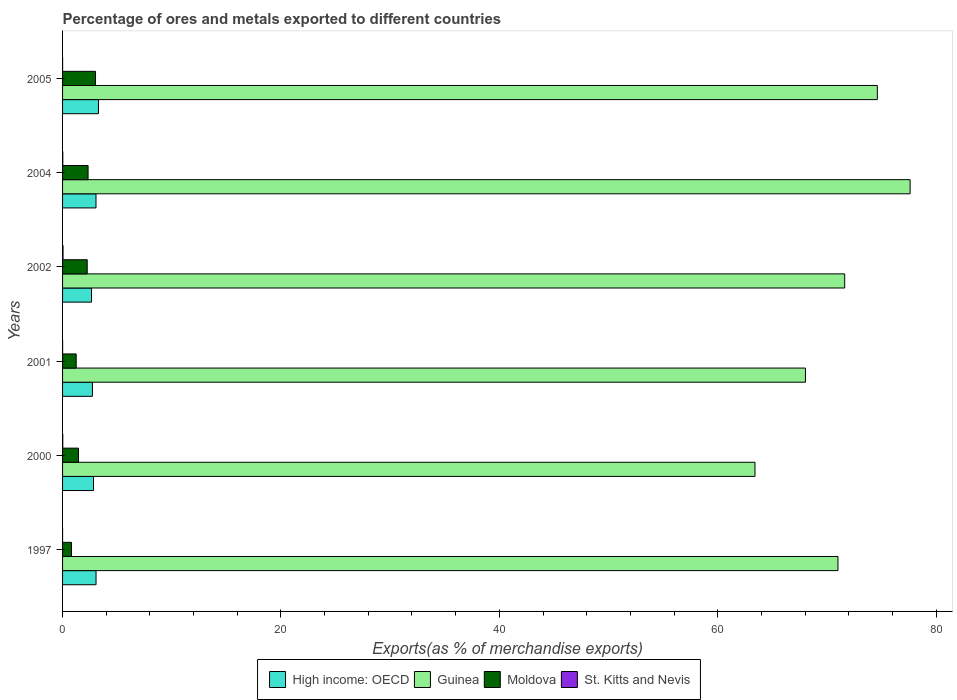Are the number of bars on each tick of the Y-axis equal?
Offer a very short reply. Yes. How many bars are there on the 6th tick from the top?
Offer a terse response. 4. What is the percentage of exports to different countries in Guinea in 2004?
Ensure brevity in your answer.  77.62. Across all years, what is the maximum percentage of exports to different countries in Moldova?
Provide a short and direct response. 3.02. Across all years, what is the minimum percentage of exports to different countries in Guinea?
Ensure brevity in your answer.  63.41. In which year was the percentage of exports to different countries in Guinea maximum?
Make the answer very short. 2004. In which year was the percentage of exports to different countries in High income: OECD minimum?
Your answer should be compact. 2002. What is the total percentage of exports to different countries in Guinea in the graph?
Your answer should be compact. 426.32. What is the difference between the percentage of exports to different countries in High income: OECD in 2000 and that in 2004?
Your answer should be compact. -0.23. What is the difference between the percentage of exports to different countries in High income: OECD in 1997 and the percentage of exports to different countries in Moldova in 2002?
Keep it short and to the point. 0.81. What is the average percentage of exports to different countries in Guinea per year?
Give a very brief answer. 71.05. In the year 2004, what is the difference between the percentage of exports to different countries in Guinea and percentage of exports to different countries in St. Kitts and Nevis?
Offer a terse response. 77.6. What is the ratio of the percentage of exports to different countries in Guinea in 2000 to that in 2002?
Give a very brief answer. 0.89. What is the difference between the highest and the second highest percentage of exports to different countries in High income: OECD?
Offer a very short reply. 0.22. What is the difference between the highest and the lowest percentage of exports to different countries in High income: OECD?
Offer a terse response. 0.63. Is the sum of the percentage of exports to different countries in Moldova in 2001 and 2002 greater than the maximum percentage of exports to different countries in High income: OECD across all years?
Offer a very short reply. Yes. What does the 1st bar from the top in 2001 represents?
Your answer should be very brief. St. Kitts and Nevis. What does the 3rd bar from the bottom in 1997 represents?
Your response must be concise. Moldova. How many bars are there?
Your answer should be compact. 24. What is the difference between two consecutive major ticks on the X-axis?
Offer a terse response. 20. Are the values on the major ticks of X-axis written in scientific E-notation?
Provide a short and direct response. No. Does the graph contain grids?
Your answer should be compact. No. Where does the legend appear in the graph?
Provide a succinct answer. Bottom center. How many legend labels are there?
Provide a short and direct response. 4. How are the legend labels stacked?
Give a very brief answer. Horizontal. What is the title of the graph?
Offer a terse response. Percentage of ores and metals exported to different countries. What is the label or title of the X-axis?
Offer a terse response. Exports(as % of merchandise exports). What is the Exports(as % of merchandise exports) of High income: OECD in 1997?
Keep it short and to the point. 3.07. What is the Exports(as % of merchandise exports) of Guinea in 1997?
Your answer should be very brief. 71.01. What is the Exports(as % of merchandise exports) in Moldova in 1997?
Make the answer very short. 0.82. What is the Exports(as % of merchandise exports) of St. Kitts and Nevis in 1997?
Provide a succinct answer. 0. What is the Exports(as % of merchandise exports) of High income: OECD in 2000?
Give a very brief answer. 2.83. What is the Exports(as % of merchandise exports) in Guinea in 2000?
Keep it short and to the point. 63.41. What is the Exports(as % of merchandise exports) in Moldova in 2000?
Offer a terse response. 1.46. What is the Exports(as % of merchandise exports) in St. Kitts and Nevis in 2000?
Your response must be concise. 0.02. What is the Exports(as % of merchandise exports) of High income: OECD in 2001?
Your answer should be very brief. 2.73. What is the Exports(as % of merchandise exports) of Guinea in 2001?
Keep it short and to the point. 68.03. What is the Exports(as % of merchandise exports) of Moldova in 2001?
Your answer should be very brief. 1.25. What is the Exports(as % of merchandise exports) in St. Kitts and Nevis in 2001?
Offer a very short reply. 0. What is the Exports(as % of merchandise exports) of High income: OECD in 2002?
Give a very brief answer. 2.65. What is the Exports(as % of merchandise exports) of Guinea in 2002?
Offer a very short reply. 71.63. What is the Exports(as % of merchandise exports) in Moldova in 2002?
Provide a short and direct response. 2.26. What is the Exports(as % of merchandise exports) in St. Kitts and Nevis in 2002?
Your answer should be compact. 0.04. What is the Exports(as % of merchandise exports) in High income: OECD in 2004?
Give a very brief answer. 3.06. What is the Exports(as % of merchandise exports) of Guinea in 2004?
Your response must be concise. 77.62. What is the Exports(as % of merchandise exports) of Moldova in 2004?
Your response must be concise. 2.34. What is the Exports(as % of merchandise exports) of St. Kitts and Nevis in 2004?
Offer a terse response. 0.02. What is the Exports(as % of merchandise exports) of High income: OECD in 2005?
Make the answer very short. 3.29. What is the Exports(as % of merchandise exports) in Guinea in 2005?
Provide a succinct answer. 74.62. What is the Exports(as % of merchandise exports) of Moldova in 2005?
Give a very brief answer. 3.02. What is the Exports(as % of merchandise exports) of St. Kitts and Nevis in 2005?
Your answer should be very brief. 0. Across all years, what is the maximum Exports(as % of merchandise exports) of High income: OECD?
Offer a very short reply. 3.29. Across all years, what is the maximum Exports(as % of merchandise exports) in Guinea?
Your answer should be compact. 77.62. Across all years, what is the maximum Exports(as % of merchandise exports) of Moldova?
Provide a short and direct response. 3.02. Across all years, what is the maximum Exports(as % of merchandise exports) in St. Kitts and Nevis?
Provide a short and direct response. 0.04. Across all years, what is the minimum Exports(as % of merchandise exports) of High income: OECD?
Offer a very short reply. 2.65. Across all years, what is the minimum Exports(as % of merchandise exports) of Guinea?
Offer a terse response. 63.41. Across all years, what is the minimum Exports(as % of merchandise exports) in Moldova?
Provide a succinct answer. 0.82. Across all years, what is the minimum Exports(as % of merchandise exports) in St. Kitts and Nevis?
Offer a terse response. 0. What is the total Exports(as % of merchandise exports) in High income: OECD in the graph?
Ensure brevity in your answer.  17.64. What is the total Exports(as % of merchandise exports) in Guinea in the graph?
Make the answer very short. 426.32. What is the total Exports(as % of merchandise exports) in Moldova in the graph?
Keep it short and to the point. 11.13. What is the total Exports(as % of merchandise exports) of St. Kitts and Nevis in the graph?
Keep it short and to the point. 0.09. What is the difference between the Exports(as % of merchandise exports) in High income: OECD in 1997 and that in 2000?
Keep it short and to the point. 0.23. What is the difference between the Exports(as % of merchandise exports) of Moldova in 1997 and that in 2000?
Keep it short and to the point. -0.64. What is the difference between the Exports(as % of merchandise exports) in St. Kitts and Nevis in 1997 and that in 2000?
Keep it short and to the point. -0.02. What is the difference between the Exports(as % of merchandise exports) in High income: OECD in 1997 and that in 2001?
Your answer should be compact. 0.33. What is the difference between the Exports(as % of merchandise exports) in Guinea in 1997 and that in 2001?
Offer a terse response. 2.98. What is the difference between the Exports(as % of merchandise exports) of Moldova in 1997 and that in 2001?
Offer a terse response. -0.43. What is the difference between the Exports(as % of merchandise exports) in St. Kitts and Nevis in 1997 and that in 2001?
Offer a very short reply. -0. What is the difference between the Exports(as % of merchandise exports) of High income: OECD in 1997 and that in 2002?
Offer a terse response. 0.41. What is the difference between the Exports(as % of merchandise exports) of Guinea in 1997 and that in 2002?
Keep it short and to the point. -0.61. What is the difference between the Exports(as % of merchandise exports) of Moldova in 1997 and that in 2002?
Offer a very short reply. -1.44. What is the difference between the Exports(as % of merchandise exports) in St. Kitts and Nevis in 1997 and that in 2002?
Your answer should be compact. -0.04. What is the difference between the Exports(as % of merchandise exports) of High income: OECD in 1997 and that in 2004?
Your answer should be very brief. 0. What is the difference between the Exports(as % of merchandise exports) in Guinea in 1997 and that in 2004?
Offer a very short reply. -6.61. What is the difference between the Exports(as % of merchandise exports) of Moldova in 1997 and that in 2004?
Provide a short and direct response. -1.52. What is the difference between the Exports(as % of merchandise exports) in St. Kitts and Nevis in 1997 and that in 2004?
Ensure brevity in your answer.  -0.02. What is the difference between the Exports(as % of merchandise exports) of High income: OECD in 1997 and that in 2005?
Offer a terse response. -0.22. What is the difference between the Exports(as % of merchandise exports) in Guinea in 1997 and that in 2005?
Ensure brevity in your answer.  -3.61. What is the difference between the Exports(as % of merchandise exports) in Moldova in 1997 and that in 2005?
Your response must be concise. -2.2. What is the difference between the Exports(as % of merchandise exports) of St. Kitts and Nevis in 1997 and that in 2005?
Provide a succinct answer. -0. What is the difference between the Exports(as % of merchandise exports) of High income: OECD in 2000 and that in 2001?
Give a very brief answer. 0.1. What is the difference between the Exports(as % of merchandise exports) in Guinea in 2000 and that in 2001?
Your answer should be compact. -4.62. What is the difference between the Exports(as % of merchandise exports) in Moldova in 2000 and that in 2001?
Offer a very short reply. 0.21. What is the difference between the Exports(as % of merchandise exports) of St. Kitts and Nevis in 2000 and that in 2001?
Give a very brief answer. 0.02. What is the difference between the Exports(as % of merchandise exports) of High income: OECD in 2000 and that in 2002?
Ensure brevity in your answer.  0.18. What is the difference between the Exports(as % of merchandise exports) of Guinea in 2000 and that in 2002?
Keep it short and to the point. -8.21. What is the difference between the Exports(as % of merchandise exports) in Moldova in 2000 and that in 2002?
Your answer should be very brief. -0.8. What is the difference between the Exports(as % of merchandise exports) in St. Kitts and Nevis in 2000 and that in 2002?
Ensure brevity in your answer.  -0.02. What is the difference between the Exports(as % of merchandise exports) of High income: OECD in 2000 and that in 2004?
Keep it short and to the point. -0.23. What is the difference between the Exports(as % of merchandise exports) in Guinea in 2000 and that in 2004?
Offer a very short reply. -14.21. What is the difference between the Exports(as % of merchandise exports) in Moldova in 2000 and that in 2004?
Give a very brief answer. -0.88. What is the difference between the Exports(as % of merchandise exports) in St. Kitts and Nevis in 2000 and that in 2004?
Provide a succinct answer. -0. What is the difference between the Exports(as % of merchandise exports) of High income: OECD in 2000 and that in 2005?
Ensure brevity in your answer.  -0.45. What is the difference between the Exports(as % of merchandise exports) in Guinea in 2000 and that in 2005?
Keep it short and to the point. -11.21. What is the difference between the Exports(as % of merchandise exports) in Moldova in 2000 and that in 2005?
Provide a short and direct response. -1.56. What is the difference between the Exports(as % of merchandise exports) in St. Kitts and Nevis in 2000 and that in 2005?
Make the answer very short. 0.02. What is the difference between the Exports(as % of merchandise exports) in High income: OECD in 2001 and that in 2002?
Your answer should be compact. 0.08. What is the difference between the Exports(as % of merchandise exports) in Guinea in 2001 and that in 2002?
Your answer should be compact. -3.59. What is the difference between the Exports(as % of merchandise exports) in Moldova in 2001 and that in 2002?
Your answer should be compact. -1.01. What is the difference between the Exports(as % of merchandise exports) in St. Kitts and Nevis in 2001 and that in 2002?
Provide a short and direct response. -0.04. What is the difference between the Exports(as % of merchandise exports) in High income: OECD in 2001 and that in 2004?
Provide a short and direct response. -0.33. What is the difference between the Exports(as % of merchandise exports) of Guinea in 2001 and that in 2004?
Ensure brevity in your answer.  -9.58. What is the difference between the Exports(as % of merchandise exports) of Moldova in 2001 and that in 2004?
Offer a very short reply. -1.09. What is the difference between the Exports(as % of merchandise exports) in St. Kitts and Nevis in 2001 and that in 2004?
Keep it short and to the point. -0.02. What is the difference between the Exports(as % of merchandise exports) in High income: OECD in 2001 and that in 2005?
Your response must be concise. -0.55. What is the difference between the Exports(as % of merchandise exports) of Guinea in 2001 and that in 2005?
Give a very brief answer. -6.58. What is the difference between the Exports(as % of merchandise exports) of Moldova in 2001 and that in 2005?
Your answer should be compact. -1.77. What is the difference between the Exports(as % of merchandise exports) in St. Kitts and Nevis in 2001 and that in 2005?
Your answer should be very brief. 0. What is the difference between the Exports(as % of merchandise exports) in High income: OECD in 2002 and that in 2004?
Make the answer very short. -0.41. What is the difference between the Exports(as % of merchandise exports) in Guinea in 2002 and that in 2004?
Your response must be concise. -5.99. What is the difference between the Exports(as % of merchandise exports) of Moldova in 2002 and that in 2004?
Keep it short and to the point. -0.08. What is the difference between the Exports(as % of merchandise exports) of St. Kitts and Nevis in 2002 and that in 2004?
Provide a short and direct response. 0.02. What is the difference between the Exports(as % of merchandise exports) of High income: OECD in 2002 and that in 2005?
Provide a short and direct response. -0.63. What is the difference between the Exports(as % of merchandise exports) of Guinea in 2002 and that in 2005?
Provide a succinct answer. -2.99. What is the difference between the Exports(as % of merchandise exports) in Moldova in 2002 and that in 2005?
Your answer should be compact. -0.76. What is the difference between the Exports(as % of merchandise exports) in High income: OECD in 2004 and that in 2005?
Keep it short and to the point. -0.22. What is the difference between the Exports(as % of merchandise exports) of Guinea in 2004 and that in 2005?
Provide a succinct answer. 3. What is the difference between the Exports(as % of merchandise exports) of Moldova in 2004 and that in 2005?
Give a very brief answer. -0.68. What is the difference between the Exports(as % of merchandise exports) in St. Kitts and Nevis in 2004 and that in 2005?
Offer a very short reply. 0.02. What is the difference between the Exports(as % of merchandise exports) of High income: OECD in 1997 and the Exports(as % of merchandise exports) of Guinea in 2000?
Provide a succinct answer. -60.35. What is the difference between the Exports(as % of merchandise exports) of High income: OECD in 1997 and the Exports(as % of merchandise exports) of Moldova in 2000?
Offer a terse response. 1.61. What is the difference between the Exports(as % of merchandise exports) of High income: OECD in 1997 and the Exports(as % of merchandise exports) of St. Kitts and Nevis in 2000?
Make the answer very short. 3.05. What is the difference between the Exports(as % of merchandise exports) in Guinea in 1997 and the Exports(as % of merchandise exports) in Moldova in 2000?
Keep it short and to the point. 69.55. What is the difference between the Exports(as % of merchandise exports) of Guinea in 1997 and the Exports(as % of merchandise exports) of St. Kitts and Nevis in 2000?
Offer a very short reply. 70.99. What is the difference between the Exports(as % of merchandise exports) in Moldova in 1997 and the Exports(as % of merchandise exports) in St. Kitts and Nevis in 2000?
Provide a succinct answer. 0.8. What is the difference between the Exports(as % of merchandise exports) in High income: OECD in 1997 and the Exports(as % of merchandise exports) in Guinea in 2001?
Give a very brief answer. -64.97. What is the difference between the Exports(as % of merchandise exports) in High income: OECD in 1997 and the Exports(as % of merchandise exports) in Moldova in 2001?
Your answer should be compact. 1.82. What is the difference between the Exports(as % of merchandise exports) in High income: OECD in 1997 and the Exports(as % of merchandise exports) in St. Kitts and Nevis in 2001?
Provide a succinct answer. 3.06. What is the difference between the Exports(as % of merchandise exports) in Guinea in 1997 and the Exports(as % of merchandise exports) in Moldova in 2001?
Keep it short and to the point. 69.76. What is the difference between the Exports(as % of merchandise exports) in Guinea in 1997 and the Exports(as % of merchandise exports) in St. Kitts and Nevis in 2001?
Offer a terse response. 71.01. What is the difference between the Exports(as % of merchandise exports) of Moldova in 1997 and the Exports(as % of merchandise exports) of St. Kitts and Nevis in 2001?
Provide a succinct answer. 0.81. What is the difference between the Exports(as % of merchandise exports) in High income: OECD in 1997 and the Exports(as % of merchandise exports) in Guinea in 2002?
Make the answer very short. -68.56. What is the difference between the Exports(as % of merchandise exports) in High income: OECD in 1997 and the Exports(as % of merchandise exports) in Moldova in 2002?
Your answer should be compact. 0.81. What is the difference between the Exports(as % of merchandise exports) of High income: OECD in 1997 and the Exports(as % of merchandise exports) of St. Kitts and Nevis in 2002?
Your answer should be very brief. 3.02. What is the difference between the Exports(as % of merchandise exports) in Guinea in 1997 and the Exports(as % of merchandise exports) in Moldova in 2002?
Your answer should be very brief. 68.76. What is the difference between the Exports(as % of merchandise exports) in Guinea in 1997 and the Exports(as % of merchandise exports) in St. Kitts and Nevis in 2002?
Keep it short and to the point. 70.97. What is the difference between the Exports(as % of merchandise exports) in Moldova in 1997 and the Exports(as % of merchandise exports) in St. Kitts and Nevis in 2002?
Offer a terse response. 0.78. What is the difference between the Exports(as % of merchandise exports) of High income: OECD in 1997 and the Exports(as % of merchandise exports) of Guinea in 2004?
Your answer should be very brief. -74.55. What is the difference between the Exports(as % of merchandise exports) of High income: OECD in 1997 and the Exports(as % of merchandise exports) of Moldova in 2004?
Your answer should be very brief. 0.73. What is the difference between the Exports(as % of merchandise exports) of High income: OECD in 1997 and the Exports(as % of merchandise exports) of St. Kitts and Nevis in 2004?
Provide a succinct answer. 3.04. What is the difference between the Exports(as % of merchandise exports) of Guinea in 1997 and the Exports(as % of merchandise exports) of Moldova in 2004?
Make the answer very short. 68.68. What is the difference between the Exports(as % of merchandise exports) in Guinea in 1997 and the Exports(as % of merchandise exports) in St. Kitts and Nevis in 2004?
Provide a succinct answer. 70.99. What is the difference between the Exports(as % of merchandise exports) of Moldova in 1997 and the Exports(as % of merchandise exports) of St. Kitts and Nevis in 2004?
Your answer should be very brief. 0.8. What is the difference between the Exports(as % of merchandise exports) of High income: OECD in 1997 and the Exports(as % of merchandise exports) of Guinea in 2005?
Your answer should be compact. -71.55. What is the difference between the Exports(as % of merchandise exports) of High income: OECD in 1997 and the Exports(as % of merchandise exports) of Moldova in 2005?
Give a very brief answer. 0.05. What is the difference between the Exports(as % of merchandise exports) in High income: OECD in 1997 and the Exports(as % of merchandise exports) in St. Kitts and Nevis in 2005?
Provide a short and direct response. 3.06. What is the difference between the Exports(as % of merchandise exports) in Guinea in 1997 and the Exports(as % of merchandise exports) in Moldova in 2005?
Your answer should be very brief. 67.99. What is the difference between the Exports(as % of merchandise exports) in Guinea in 1997 and the Exports(as % of merchandise exports) in St. Kitts and Nevis in 2005?
Make the answer very short. 71.01. What is the difference between the Exports(as % of merchandise exports) in Moldova in 1997 and the Exports(as % of merchandise exports) in St. Kitts and Nevis in 2005?
Your answer should be very brief. 0.82. What is the difference between the Exports(as % of merchandise exports) of High income: OECD in 2000 and the Exports(as % of merchandise exports) of Guinea in 2001?
Ensure brevity in your answer.  -65.2. What is the difference between the Exports(as % of merchandise exports) in High income: OECD in 2000 and the Exports(as % of merchandise exports) in Moldova in 2001?
Your answer should be very brief. 1.59. What is the difference between the Exports(as % of merchandise exports) of High income: OECD in 2000 and the Exports(as % of merchandise exports) of St. Kitts and Nevis in 2001?
Offer a very short reply. 2.83. What is the difference between the Exports(as % of merchandise exports) in Guinea in 2000 and the Exports(as % of merchandise exports) in Moldova in 2001?
Offer a terse response. 62.16. What is the difference between the Exports(as % of merchandise exports) in Guinea in 2000 and the Exports(as % of merchandise exports) in St. Kitts and Nevis in 2001?
Provide a succinct answer. 63.41. What is the difference between the Exports(as % of merchandise exports) in Moldova in 2000 and the Exports(as % of merchandise exports) in St. Kitts and Nevis in 2001?
Ensure brevity in your answer.  1.45. What is the difference between the Exports(as % of merchandise exports) in High income: OECD in 2000 and the Exports(as % of merchandise exports) in Guinea in 2002?
Your response must be concise. -68.79. What is the difference between the Exports(as % of merchandise exports) in High income: OECD in 2000 and the Exports(as % of merchandise exports) in Moldova in 2002?
Provide a succinct answer. 0.58. What is the difference between the Exports(as % of merchandise exports) in High income: OECD in 2000 and the Exports(as % of merchandise exports) in St. Kitts and Nevis in 2002?
Your answer should be compact. 2.79. What is the difference between the Exports(as % of merchandise exports) of Guinea in 2000 and the Exports(as % of merchandise exports) of Moldova in 2002?
Your response must be concise. 61.16. What is the difference between the Exports(as % of merchandise exports) of Guinea in 2000 and the Exports(as % of merchandise exports) of St. Kitts and Nevis in 2002?
Make the answer very short. 63.37. What is the difference between the Exports(as % of merchandise exports) of Moldova in 2000 and the Exports(as % of merchandise exports) of St. Kitts and Nevis in 2002?
Make the answer very short. 1.42. What is the difference between the Exports(as % of merchandise exports) of High income: OECD in 2000 and the Exports(as % of merchandise exports) of Guinea in 2004?
Your answer should be very brief. -74.78. What is the difference between the Exports(as % of merchandise exports) in High income: OECD in 2000 and the Exports(as % of merchandise exports) in Moldova in 2004?
Provide a short and direct response. 0.5. What is the difference between the Exports(as % of merchandise exports) of High income: OECD in 2000 and the Exports(as % of merchandise exports) of St. Kitts and Nevis in 2004?
Provide a short and direct response. 2.81. What is the difference between the Exports(as % of merchandise exports) of Guinea in 2000 and the Exports(as % of merchandise exports) of Moldova in 2004?
Give a very brief answer. 61.08. What is the difference between the Exports(as % of merchandise exports) of Guinea in 2000 and the Exports(as % of merchandise exports) of St. Kitts and Nevis in 2004?
Offer a terse response. 63.39. What is the difference between the Exports(as % of merchandise exports) of Moldova in 2000 and the Exports(as % of merchandise exports) of St. Kitts and Nevis in 2004?
Your answer should be very brief. 1.44. What is the difference between the Exports(as % of merchandise exports) in High income: OECD in 2000 and the Exports(as % of merchandise exports) in Guinea in 2005?
Your answer should be very brief. -71.78. What is the difference between the Exports(as % of merchandise exports) in High income: OECD in 2000 and the Exports(as % of merchandise exports) in Moldova in 2005?
Your response must be concise. -0.18. What is the difference between the Exports(as % of merchandise exports) of High income: OECD in 2000 and the Exports(as % of merchandise exports) of St. Kitts and Nevis in 2005?
Keep it short and to the point. 2.83. What is the difference between the Exports(as % of merchandise exports) in Guinea in 2000 and the Exports(as % of merchandise exports) in Moldova in 2005?
Provide a succinct answer. 60.39. What is the difference between the Exports(as % of merchandise exports) of Guinea in 2000 and the Exports(as % of merchandise exports) of St. Kitts and Nevis in 2005?
Your response must be concise. 63.41. What is the difference between the Exports(as % of merchandise exports) in Moldova in 2000 and the Exports(as % of merchandise exports) in St. Kitts and Nevis in 2005?
Provide a short and direct response. 1.46. What is the difference between the Exports(as % of merchandise exports) of High income: OECD in 2001 and the Exports(as % of merchandise exports) of Guinea in 2002?
Give a very brief answer. -68.89. What is the difference between the Exports(as % of merchandise exports) in High income: OECD in 2001 and the Exports(as % of merchandise exports) in Moldova in 2002?
Your answer should be compact. 0.48. What is the difference between the Exports(as % of merchandise exports) in High income: OECD in 2001 and the Exports(as % of merchandise exports) in St. Kitts and Nevis in 2002?
Ensure brevity in your answer.  2.69. What is the difference between the Exports(as % of merchandise exports) of Guinea in 2001 and the Exports(as % of merchandise exports) of Moldova in 2002?
Provide a succinct answer. 65.78. What is the difference between the Exports(as % of merchandise exports) in Guinea in 2001 and the Exports(as % of merchandise exports) in St. Kitts and Nevis in 2002?
Give a very brief answer. 67.99. What is the difference between the Exports(as % of merchandise exports) in Moldova in 2001 and the Exports(as % of merchandise exports) in St. Kitts and Nevis in 2002?
Offer a very short reply. 1.2. What is the difference between the Exports(as % of merchandise exports) of High income: OECD in 2001 and the Exports(as % of merchandise exports) of Guinea in 2004?
Make the answer very short. -74.88. What is the difference between the Exports(as % of merchandise exports) of High income: OECD in 2001 and the Exports(as % of merchandise exports) of Moldova in 2004?
Make the answer very short. 0.4. What is the difference between the Exports(as % of merchandise exports) in High income: OECD in 2001 and the Exports(as % of merchandise exports) in St. Kitts and Nevis in 2004?
Your answer should be compact. 2.71. What is the difference between the Exports(as % of merchandise exports) of Guinea in 2001 and the Exports(as % of merchandise exports) of Moldova in 2004?
Provide a succinct answer. 65.7. What is the difference between the Exports(as % of merchandise exports) in Guinea in 2001 and the Exports(as % of merchandise exports) in St. Kitts and Nevis in 2004?
Your answer should be very brief. 68.01. What is the difference between the Exports(as % of merchandise exports) of Moldova in 2001 and the Exports(as % of merchandise exports) of St. Kitts and Nevis in 2004?
Your response must be concise. 1.23. What is the difference between the Exports(as % of merchandise exports) of High income: OECD in 2001 and the Exports(as % of merchandise exports) of Guinea in 2005?
Provide a short and direct response. -71.88. What is the difference between the Exports(as % of merchandise exports) of High income: OECD in 2001 and the Exports(as % of merchandise exports) of Moldova in 2005?
Keep it short and to the point. -0.28. What is the difference between the Exports(as % of merchandise exports) in High income: OECD in 2001 and the Exports(as % of merchandise exports) in St. Kitts and Nevis in 2005?
Your answer should be very brief. 2.73. What is the difference between the Exports(as % of merchandise exports) of Guinea in 2001 and the Exports(as % of merchandise exports) of Moldova in 2005?
Keep it short and to the point. 65.02. What is the difference between the Exports(as % of merchandise exports) in Guinea in 2001 and the Exports(as % of merchandise exports) in St. Kitts and Nevis in 2005?
Offer a very short reply. 68.03. What is the difference between the Exports(as % of merchandise exports) in Moldova in 2001 and the Exports(as % of merchandise exports) in St. Kitts and Nevis in 2005?
Offer a terse response. 1.24. What is the difference between the Exports(as % of merchandise exports) of High income: OECD in 2002 and the Exports(as % of merchandise exports) of Guinea in 2004?
Provide a short and direct response. -74.96. What is the difference between the Exports(as % of merchandise exports) of High income: OECD in 2002 and the Exports(as % of merchandise exports) of Moldova in 2004?
Provide a succinct answer. 0.32. What is the difference between the Exports(as % of merchandise exports) in High income: OECD in 2002 and the Exports(as % of merchandise exports) in St. Kitts and Nevis in 2004?
Ensure brevity in your answer.  2.63. What is the difference between the Exports(as % of merchandise exports) in Guinea in 2002 and the Exports(as % of merchandise exports) in Moldova in 2004?
Keep it short and to the point. 69.29. What is the difference between the Exports(as % of merchandise exports) in Guinea in 2002 and the Exports(as % of merchandise exports) in St. Kitts and Nevis in 2004?
Provide a short and direct response. 71.6. What is the difference between the Exports(as % of merchandise exports) of Moldova in 2002 and the Exports(as % of merchandise exports) of St. Kitts and Nevis in 2004?
Offer a very short reply. 2.24. What is the difference between the Exports(as % of merchandise exports) of High income: OECD in 2002 and the Exports(as % of merchandise exports) of Guinea in 2005?
Give a very brief answer. -71.96. What is the difference between the Exports(as % of merchandise exports) of High income: OECD in 2002 and the Exports(as % of merchandise exports) of Moldova in 2005?
Ensure brevity in your answer.  -0.36. What is the difference between the Exports(as % of merchandise exports) of High income: OECD in 2002 and the Exports(as % of merchandise exports) of St. Kitts and Nevis in 2005?
Your response must be concise. 2.65. What is the difference between the Exports(as % of merchandise exports) of Guinea in 2002 and the Exports(as % of merchandise exports) of Moldova in 2005?
Your answer should be very brief. 68.61. What is the difference between the Exports(as % of merchandise exports) in Guinea in 2002 and the Exports(as % of merchandise exports) in St. Kitts and Nevis in 2005?
Your answer should be very brief. 71.62. What is the difference between the Exports(as % of merchandise exports) in Moldova in 2002 and the Exports(as % of merchandise exports) in St. Kitts and Nevis in 2005?
Provide a succinct answer. 2.25. What is the difference between the Exports(as % of merchandise exports) in High income: OECD in 2004 and the Exports(as % of merchandise exports) in Guinea in 2005?
Your response must be concise. -71.55. What is the difference between the Exports(as % of merchandise exports) of High income: OECD in 2004 and the Exports(as % of merchandise exports) of Moldova in 2005?
Your answer should be compact. 0.04. What is the difference between the Exports(as % of merchandise exports) of High income: OECD in 2004 and the Exports(as % of merchandise exports) of St. Kitts and Nevis in 2005?
Provide a succinct answer. 3.06. What is the difference between the Exports(as % of merchandise exports) of Guinea in 2004 and the Exports(as % of merchandise exports) of Moldova in 2005?
Ensure brevity in your answer.  74.6. What is the difference between the Exports(as % of merchandise exports) in Guinea in 2004 and the Exports(as % of merchandise exports) in St. Kitts and Nevis in 2005?
Provide a succinct answer. 77.62. What is the difference between the Exports(as % of merchandise exports) in Moldova in 2004 and the Exports(as % of merchandise exports) in St. Kitts and Nevis in 2005?
Offer a very short reply. 2.33. What is the average Exports(as % of merchandise exports) in High income: OECD per year?
Your response must be concise. 2.94. What is the average Exports(as % of merchandise exports) of Guinea per year?
Offer a terse response. 71.05. What is the average Exports(as % of merchandise exports) of Moldova per year?
Your answer should be compact. 1.86. What is the average Exports(as % of merchandise exports) of St. Kitts and Nevis per year?
Offer a very short reply. 0.01. In the year 1997, what is the difference between the Exports(as % of merchandise exports) in High income: OECD and Exports(as % of merchandise exports) in Guinea?
Offer a terse response. -67.95. In the year 1997, what is the difference between the Exports(as % of merchandise exports) of High income: OECD and Exports(as % of merchandise exports) of Moldova?
Offer a terse response. 2.25. In the year 1997, what is the difference between the Exports(as % of merchandise exports) in High income: OECD and Exports(as % of merchandise exports) in St. Kitts and Nevis?
Offer a terse response. 3.07. In the year 1997, what is the difference between the Exports(as % of merchandise exports) of Guinea and Exports(as % of merchandise exports) of Moldova?
Ensure brevity in your answer.  70.19. In the year 1997, what is the difference between the Exports(as % of merchandise exports) in Guinea and Exports(as % of merchandise exports) in St. Kitts and Nevis?
Offer a terse response. 71.01. In the year 1997, what is the difference between the Exports(as % of merchandise exports) of Moldova and Exports(as % of merchandise exports) of St. Kitts and Nevis?
Ensure brevity in your answer.  0.82. In the year 2000, what is the difference between the Exports(as % of merchandise exports) of High income: OECD and Exports(as % of merchandise exports) of Guinea?
Keep it short and to the point. -60.58. In the year 2000, what is the difference between the Exports(as % of merchandise exports) of High income: OECD and Exports(as % of merchandise exports) of Moldova?
Provide a succinct answer. 1.38. In the year 2000, what is the difference between the Exports(as % of merchandise exports) in High income: OECD and Exports(as % of merchandise exports) in St. Kitts and Nevis?
Provide a short and direct response. 2.81. In the year 2000, what is the difference between the Exports(as % of merchandise exports) in Guinea and Exports(as % of merchandise exports) in Moldova?
Make the answer very short. 61.95. In the year 2000, what is the difference between the Exports(as % of merchandise exports) in Guinea and Exports(as % of merchandise exports) in St. Kitts and Nevis?
Make the answer very short. 63.39. In the year 2000, what is the difference between the Exports(as % of merchandise exports) in Moldova and Exports(as % of merchandise exports) in St. Kitts and Nevis?
Provide a short and direct response. 1.44. In the year 2001, what is the difference between the Exports(as % of merchandise exports) of High income: OECD and Exports(as % of merchandise exports) of Guinea?
Provide a short and direct response. -65.3. In the year 2001, what is the difference between the Exports(as % of merchandise exports) in High income: OECD and Exports(as % of merchandise exports) in Moldova?
Your answer should be very brief. 1.49. In the year 2001, what is the difference between the Exports(as % of merchandise exports) in High income: OECD and Exports(as % of merchandise exports) in St. Kitts and Nevis?
Make the answer very short. 2.73. In the year 2001, what is the difference between the Exports(as % of merchandise exports) of Guinea and Exports(as % of merchandise exports) of Moldova?
Provide a short and direct response. 66.79. In the year 2001, what is the difference between the Exports(as % of merchandise exports) in Guinea and Exports(as % of merchandise exports) in St. Kitts and Nevis?
Give a very brief answer. 68.03. In the year 2001, what is the difference between the Exports(as % of merchandise exports) in Moldova and Exports(as % of merchandise exports) in St. Kitts and Nevis?
Give a very brief answer. 1.24. In the year 2002, what is the difference between the Exports(as % of merchandise exports) of High income: OECD and Exports(as % of merchandise exports) of Guinea?
Offer a very short reply. -68.97. In the year 2002, what is the difference between the Exports(as % of merchandise exports) of High income: OECD and Exports(as % of merchandise exports) of Moldova?
Provide a short and direct response. 0.4. In the year 2002, what is the difference between the Exports(as % of merchandise exports) in High income: OECD and Exports(as % of merchandise exports) in St. Kitts and Nevis?
Your answer should be very brief. 2.61. In the year 2002, what is the difference between the Exports(as % of merchandise exports) in Guinea and Exports(as % of merchandise exports) in Moldova?
Ensure brevity in your answer.  69.37. In the year 2002, what is the difference between the Exports(as % of merchandise exports) in Guinea and Exports(as % of merchandise exports) in St. Kitts and Nevis?
Give a very brief answer. 71.58. In the year 2002, what is the difference between the Exports(as % of merchandise exports) of Moldova and Exports(as % of merchandise exports) of St. Kitts and Nevis?
Provide a short and direct response. 2.21. In the year 2004, what is the difference between the Exports(as % of merchandise exports) in High income: OECD and Exports(as % of merchandise exports) in Guinea?
Offer a very short reply. -74.56. In the year 2004, what is the difference between the Exports(as % of merchandise exports) of High income: OECD and Exports(as % of merchandise exports) of Moldova?
Your answer should be compact. 0.73. In the year 2004, what is the difference between the Exports(as % of merchandise exports) in High income: OECD and Exports(as % of merchandise exports) in St. Kitts and Nevis?
Keep it short and to the point. 3.04. In the year 2004, what is the difference between the Exports(as % of merchandise exports) of Guinea and Exports(as % of merchandise exports) of Moldova?
Make the answer very short. 75.28. In the year 2004, what is the difference between the Exports(as % of merchandise exports) in Guinea and Exports(as % of merchandise exports) in St. Kitts and Nevis?
Your answer should be compact. 77.6. In the year 2004, what is the difference between the Exports(as % of merchandise exports) in Moldova and Exports(as % of merchandise exports) in St. Kitts and Nevis?
Provide a short and direct response. 2.31. In the year 2005, what is the difference between the Exports(as % of merchandise exports) in High income: OECD and Exports(as % of merchandise exports) in Guinea?
Ensure brevity in your answer.  -71.33. In the year 2005, what is the difference between the Exports(as % of merchandise exports) in High income: OECD and Exports(as % of merchandise exports) in Moldova?
Your answer should be very brief. 0.27. In the year 2005, what is the difference between the Exports(as % of merchandise exports) of High income: OECD and Exports(as % of merchandise exports) of St. Kitts and Nevis?
Make the answer very short. 3.28. In the year 2005, what is the difference between the Exports(as % of merchandise exports) of Guinea and Exports(as % of merchandise exports) of Moldova?
Your answer should be compact. 71.6. In the year 2005, what is the difference between the Exports(as % of merchandise exports) in Guinea and Exports(as % of merchandise exports) in St. Kitts and Nevis?
Your answer should be very brief. 74.61. In the year 2005, what is the difference between the Exports(as % of merchandise exports) of Moldova and Exports(as % of merchandise exports) of St. Kitts and Nevis?
Make the answer very short. 3.02. What is the ratio of the Exports(as % of merchandise exports) of High income: OECD in 1997 to that in 2000?
Make the answer very short. 1.08. What is the ratio of the Exports(as % of merchandise exports) of Guinea in 1997 to that in 2000?
Provide a succinct answer. 1.12. What is the ratio of the Exports(as % of merchandise exports) of Moldova in 1997 to that in 2000?
Your answer should be compact. 0.56. What is the ratio of the Exports(as % of merchandise exports) of St. Kitts and Nevis in 1997 to that in 2000?
Your answer should be compact. 0.01. What is the ratio of the Exports(as % of merchandise exports) of High income: OECD in 1997 to that in 2001?
Your answer should be compact. 1.12. What is the ratio of the Exports(as % of merchandise exports) of Guinea in 1997 to that in 2001?
Keep it short and to the point. 1.04. What is the ratio of the Exports(as % of merchandise exports) of Moldova in 1997 to that in 2001?
Offer a terse response. 0.66. What is the ratio of the Exports(as % of merchandise exports) of St. Kitts and Nevis in 1997 to that in 2001?
Keep it short and to the point. 0.04. What is the ratio of the Exports(as % of merchandise exports) of High income: OECD in 1997 to that in 2002?
Offer a terse response. 1.15. What is the ratio of the Exports(as % of merchandise exports) in Guinea in 1997 to that in 2002?
Your answer should be very brief. 0.99. What is the ratio of the Exports(as % of merchandise exports) in Moldova in 1997 to that in 2002?
Ensure brevity in your answer.  0.36. What is the ratio of the Exports(as % of merchandise exports) in St. Kitts and Nevis in 1997 to that in 2002?
Give a very brief answer. 0. What is the ratio of the Exports(as % of merchandise exports) of High income: OECD in 1997 to that in 2004?
Make the answer very short. 1. What is the ratio of the Exports(as % of merchandise exports) of Guinea in 1997 to that in 2004?
Make the answer very short. 0.91. What is the ratio of the Exports(as % of merchandise exports) in Moldova in 1997 to that in 2004?
Ensure brevity in your answer.  0.35. What is the ratio of the Exports(as % of merchandise exports) in St. Kitts and Nevis in 1997 to that in 2004?
Give a very brief answer. 0.01. What is the ratio of the Exports(as % of merchandise exports) in High income: OECD in 1997 to that in 2005?
Provide a short and direct response. 0.93. What is the ratio of the Exports(as % of merchandise exports) of Guinea in 1997 to that in 2005?
Your answer should be compact. 0.95. What is the ratio of the Exports(as % of merchandise exports) of Moldova in 1997 to that in 2005?
Your response must be concise. 0.27. What is the ratio of the Exports(as % of merchandise exports) in St. Kitts and Nevis in 1997 to that in 2005?
Your answer should be compact. 0.06. What is the ratio of the Exports(as % of merchandise exports) of High income: OECD in 2000 to that in 2001?
Keep it short and to the point. 1.04. What is the ratio of the Exports(as % of merchandise exports) of Guinea in 2000 to that in 2001?
Ensure brevity in your answer.  0.93. What is the ratio of the Exports(as % of merchandise exports) of Moldova in 2000 to that in 2001?
Provide a succinct answer. 1.17. What is the ratio of the Exports(as % of merchandise exports) of St. Kitts and Nevis in 2000 to that in 2001?
Provide a succinct answer. 4.93. What is the ratio of the Exports(as % of merchandise exports) in High income: OECD in 2000 to that in 2002?
Offer a terse response. 1.07. What is the ratio of the Exports(as % of merchandise exports) of Guinea in 2000 to that in 2002?
Your response must be concise. 0.89. What is the ratio of the Exports(as % of merchandise exports) of Moldova in 2000 to that in 2002?
Your answer should be very brief. 0.65. What is the ratio of the Exports(as % of merchandise exports) of St. Kitts and Nevis in 2000 to that in 2002?
Offer a very short reply. 0.46. What is the ratio of the Exports(as % of merchandise exports) in High income: OECD in 2000 to that in 2004?
Offer a terse response. 0.93. What is the ratio of the Exports(as % of merchandise exports) of Guinea in 2000 to that in 2004?
Keep it short and to the point. 0.82. What is the ratio of the Exports(as % of merchandise exports) in Moldova in 2000 to that in 2004?
Offer a very short reply. 0.62. What is the ratio of the Exports(as % of merchandise exports) of St. Kitts and Nevis in 2000 to that in 2004?
Your answer should be compact. 0.93. What is the ratio of the Exports(as % of merchandise exports) in High income: OECD in 2000 to that in 2005?
Provide a succinct answer. 0.86. What is the ratio of the Exports(as % of merchandise exports) of Guinea in 2000 to that in 2005?
Offer a terse response. 0.85. What is the ratio of the Exports(as % of merchandise exports) in Moldova in 2000 to that in 2005?
Make the answer very short. 0.48. What is the ratio of the Exports(as % of merchandise exports) of St. Kitts and Nevis in 2000 to that in 2005?
Offer a very short reply. 7.73. What is the ratio of the Exports(as % of merchandise exports) of High income: OECD in 2001 to that in 2002?
Your response must be concise. 1.03. What is the ratio of the Exports(as % of merchandise exports) in Guinea in 2001 to that in 2002?
Provide a succinct answer. 0.95. What is the ratio of the Exports(as % of merchandise exports) of Moldova in 2001 to that in 2002?
Your response must be concise. 0.55. What is the ratio of the Exports(as % of merchandise exports) of St. Kitts and Nevis in 2001 to that in 2002?
Offer a terse response. 0.09. What is the ratio of the Exports(as % of merchandise exports) in High income: OECD in 2001 to that in 2004?
Your response must be concise. 0.89. What is the ratio of the Exports(as % of merchandise exports) of Guinea in 2001 to that in 2004?
Offer a terse response. 0.88. What is the ratio of the Exports(as % of merchandise exports) in Moldova in 2001 to that in 2004?
Provide a short and direct response. 0.53. What is the ratio of the Exports(as % of merchandise exports) in St. Kitts and Nevis in 2001 to that in 2004?
Your response must be concise. 0.19. What is the ratio of the Exports(as % of merchandise exports) in High income: OECD in 2001 to that in 2005?
Your answer should be very brief. 0.83. What is the ratio of the Exports(as % of merchandise exports) of Guinea in 2001 to that in 2005?
Give a very brief answer. 0.91. What is the ratio of the Exports(as % of merchandise exports) in Moldova in 2001 to that in 2005?
Ensure brevity in your answer.  0.41. What is the ratio of the Exports(as % of merchandise exports) of St. Kitts and Nevis in 2001 to that in 2005?
Offer a very short reply. 1.57. What is the ratio of the Exports(as % of merchandise exports) in High income: OECD in 2002 to that in 2004?
Ensure brevity in your answer.  0.87. What is the ratio of the Exports(as % of merchandise exports) of Guinea in 2002 to that in 2004?
Your answer should be compact. 0.92. What is the ratio of the Exports(as % of merchandise exports) in Moldova in 2002 to that in 2004?
Ensure brevity in your answer.  0.97. What is the ratio of the Exports(as % of merchandise exports) in St. Kitts and Nevis in 2002 to that in 2004?
Make the answer very short. 2.01. What is the ratio of the Exports(as % of merchandise exports) of High income: OECD in 2002 to that in 2005?
Your answer should be very brief. 0.81. What is the ratio of the Exports(as % of merchandise exports) of Guinea in 2002 to that in 2005?
Offer a very short reply. 0.96. What is the ratio of the Exports(as % of merchandise exports) in Moldova in 2002 to that in 2005?
Ensure brevity in your answer.  0.75. What is the ratio of the Exports(as % of merchandise exports) in St. Kitts and Nevis in 2002 to that in 2005?
Ensure brevity in your answer.  16.8. What is the ratio of the Exports(as % of merchandise exports) of High income: OECD in 2004 to that in 2005?
Provide a short and direct response. 0.93. What is the ratio of the Exports(as % of merchandise exports) in Guinea in 2004 to that in 2005?
Your response must be concise. 1.04. What is the ratio of the Exports(as % of merchandise exports) in Moldova in 2004 to that in 2005?
Your answer should be compact. 0.77. What is the ratio of the Exports(as % of merchandise exports) in St. Kitts and Nevis in 2004 to that in 2005?
Your response must be concise. 8.35. What is the difference between the highest and the second highest Exports(as % of merchandise exports) of High income: OECD?
Your response must be concise. 0.22. What is the difference between the highest and the second highest Exports(as % of merchandise exports) of Guinea?
Your response must be concise. 3. What is the difference between the highest and the second highest Exports(as % of merchandise exports) in Moldova?
Make the answer very short. 0.68. What is the difference between the highest and the second highest Exports(as % of merchandise exports) in St. Kitts and Nevis?
Keep it short and to the point. 0.02. What is the difference between the highest and the lowest Exports(as % of merchandise exports) of High income: OECD?
Ensure brevity in your answer.  0.63. What is the difference between the highest and the lowest Exports(as % of merchandise exports) in Guinea?
Offer a terse response. 14.21. What is the difference between the highest and the lowest Exports(as % of merchandise exports) in Moldova?
Offer a terse response. 2.2. What is the difference between the highest and the lowest Exports(as % of merchandise exports) of St. Kitts and Nevis?
Provide a succinct answer. 0.04. 